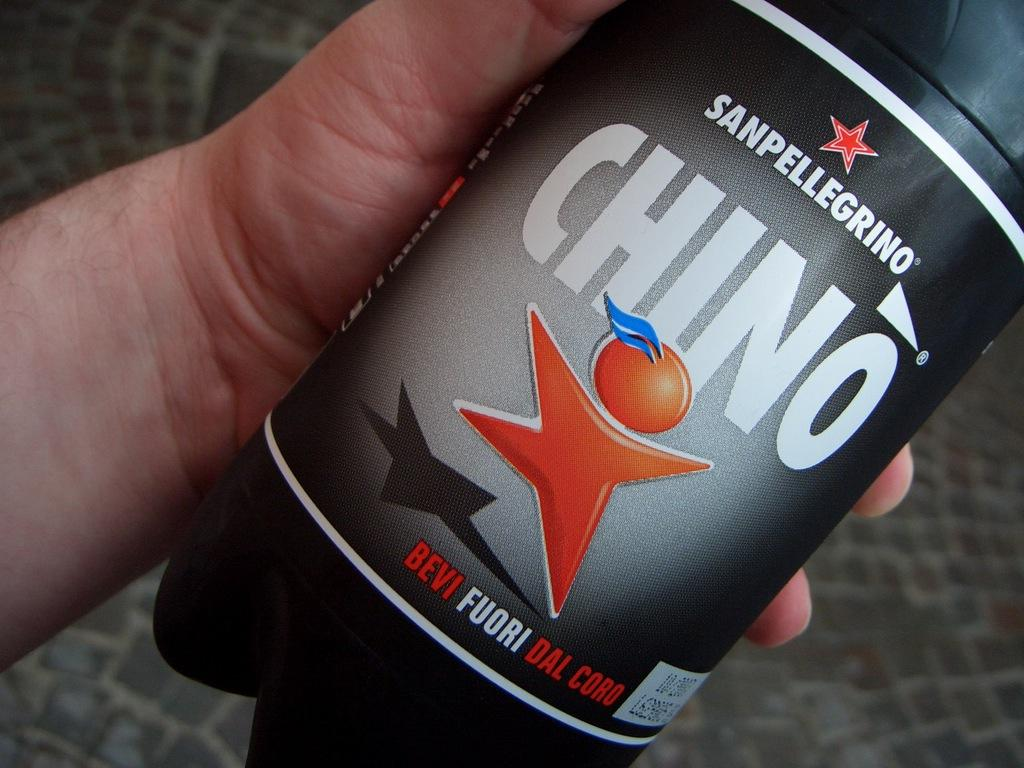What can be seen in the image related to a person's hand? There is a person's hand in the image. What is the hand holding? The hand is holding a bottle. What can be observed on the bottle? The bottle has a label. What type of voice can be heard coming from the bottle in the image? There is no voice coming from the bottle in the image; it is a physical object holding a liquid. 